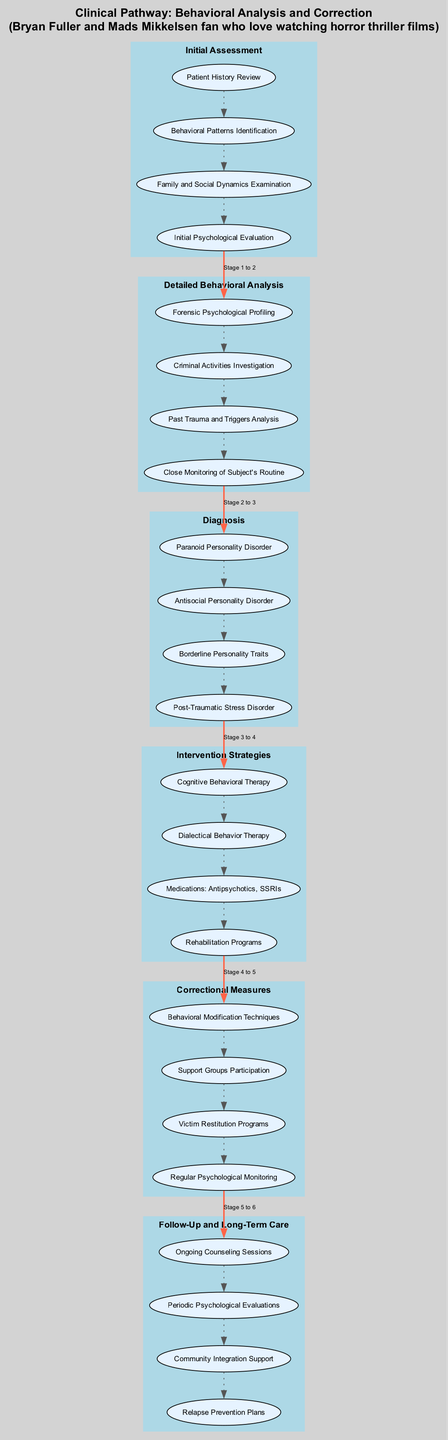What is the first stage in the Clinical Pathway? The diagram shows a sequence of stages, with the first being labeled 'Initial Assessment.'
Answer: Initial Assessment How many elements are in the 'Diagnosis' stage? By examining the 'Diagnosis' stage, we see four specific elements listed beneath it.
Answer: Four What type of therapy is mentioned as an intervention strategy? Review of the 'Intervention Strategies' shows 'Cognitive Behavioral Therapy' is one of the listed interventions.
Answer: Cognitive Behavioral Therapy Which stage follows 'Detailed Behavioral Analysis'? There is a clear flow from 'Detailed Behavioral Analysis' to the subsequent stage labeled 'Diagnosis.'
Answer: Diagnosis What does the 'Follow-Up and Long-Term Care' stage include? The 'Follow-Up and Long-Term Care' stage includes elements such as 'Ongoing Counseling Sessions,' directly listed in the diagram.
Answer: Ongoing Counseling Sessions Which disorder appears most frequently across the stages? Examining the 'Diagnosis' stage, the disorders listed do not repeat, so the answer is based purely on the current stage’s content.
Answer: None How many total stages are present in the pathway? Counting each labeled stage from the 'Behavioral Analysis and Correction' path, we see there are six distinct stages.
Answer: Six What is the final element listed in the 'Correctional Measures' stage? The last element under 'Correctional Measures' is 'Regular Psychological Monitoring,' as indicated in the diagram.
Answer: Regular Psychological Monitoring What connects the 'Initial Assessment' stage to the 'Detailed Behavioral Analysis' stage? The diagram shows a bold labeled edge connecting the last element of 'Initial Assessment' to the first element of 'Detailed Behavioral Analysis.'
Answer: A bold edge Which psychological disorder involves a history of trauma as indicated in the diagram? The 'Post-Traumatic Stress Disorder' is specifically noted under the 'Diagnosis' stage, indicating a direct connection to trauma.
Answer: Post-Traumatic Stress Disorder 